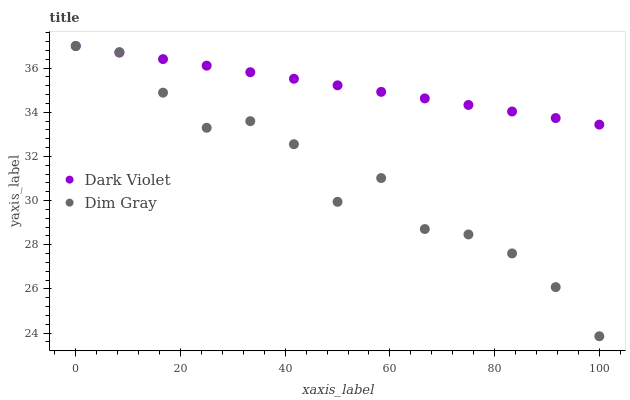Does Dim Gray have the minimum area under the curve?
Answer yes or no. Yes. Does Dark Violet have the maximum area under the curve?
Answer yes or no. Yes. Does Dark Violet have the minimum area under the curve?
Answer yes or no. No. Is Dark Violet the smoothest?
Answer yes or no. Yes. Is Dim Gray the roughest?
Answer yes or no. Yes. Is Dark Violet the roughest?
Answer yes or no. No. Does Dim Gray have the lowest value?
Answer yes or no. Yes. Does Dark Violet have the lowest value?
Answer yes or no. No. Does Dark Violet have the highest value?
Answer yes or no. Yes. Does Dim Gray intersect Dark Violet?
Answer yes or no. Yes. Is Dim Gray less than Dark Violet?
Answer yes or no. No. Is Dim Gray greater than Dark Violet?
Answer yes or no. No. 